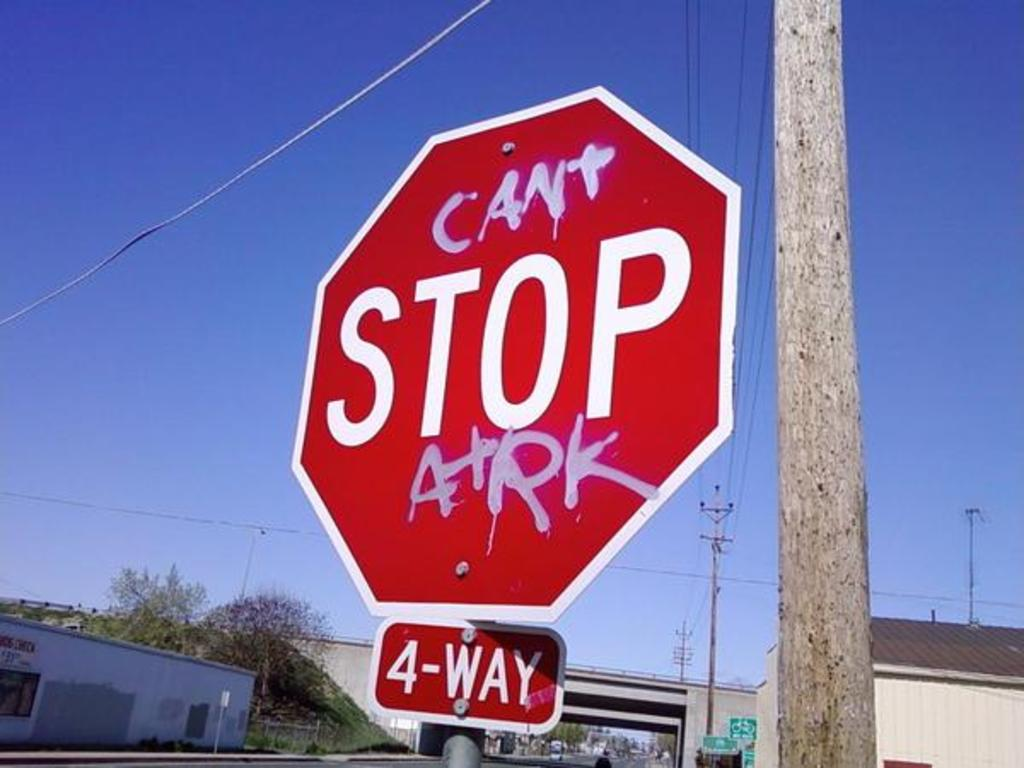Can you explain the potential implications this sign alteration might have on drivers and pedestrians? The alteration of the stop sign from 'STOP' to 'CAN'T STOP ARK' introduces a layer of humor and defiance, but it also poses potential risks. Drivers and pedestrians, used to the universal red and white signage indicating a mandatory stop, might take a moment longer to process the altered message, which could lead to confusion or even accidents. Moreover, the playful rebellion might resonate with some as a form of local identity or resistance, yet it undermines the sign's authority and essential purpose in traffic control, emphasizing the need for clarity in public safety communications. 